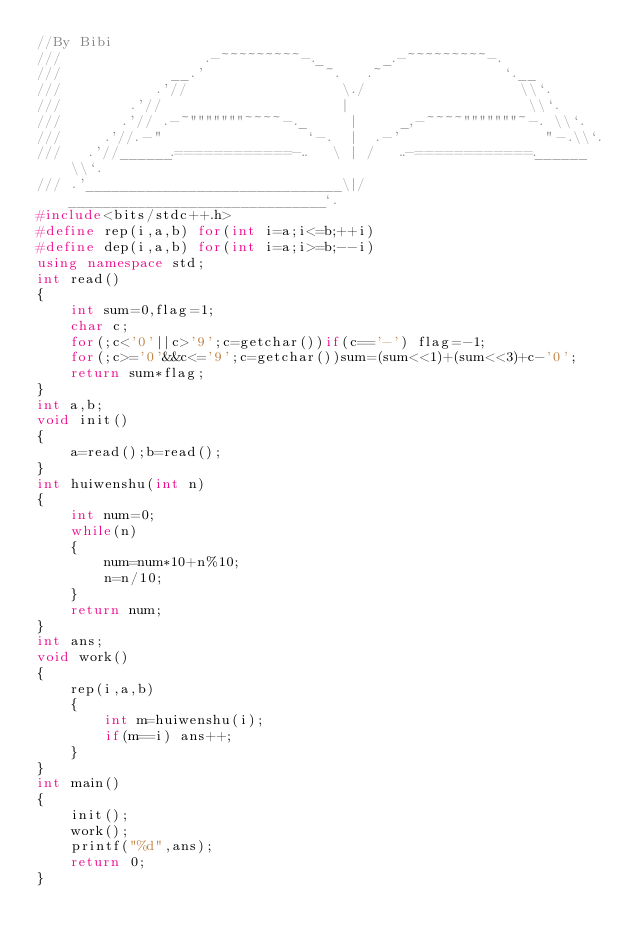<code> <loc_0><loc_0><loc_500><loc_500><_C++_>//By Bibi
///                 .-~~~~~~~~~-._       _.-~~~~~~~~~-.
///             __.'              ~.   .~              `.__
///           .'//                  \./                  \\`.
///        .'//                     |                     \\`.
///       .'// .-~"""""""~~~~-._     |     _,-~~~~"""""""~-. \\`.
///     .'//.-"                 `-.  |  .-'                 "-.\\`.
///   .'//______.============-..   \ | /   ..-============.______\\`.
/// .'______________________________\|/______________________________`.
#include<bits/stdc++.h> 
#define rep(i,a,b) for(int i=a;i<=b;++i)
#define dep(i,a,b) for(int i=a;i>=b;--i)
using namespace std;
int read()
{
	int sum=0,flag=1;
	char c;
	for(;c<'0'||c>'9';c=getchar())if(c=='-') flag=-1;
	for(;c>='0'&&c<='9';c=getchar())sum=(sum<<1)+(sum<<3)+c-'0';
	return sum*flag;
}
int a,b;
void init()
{
	a=read();b=read();
}
int huiwenshu(int n)  
{  
    int num=0;  
    while(n)  
    {  
        num=num*10+n%10;  
        n=n/10;  
    }  
    return num;  
}  
int ans;
void work()
{
	rep(i,a,b)
	{
		int m=huiwenshu(i);
		if(m==i) ans++;
	}
}
int main()
{
	init();
	work();
	printf("%d",ans);
	return 0;
}</code> 